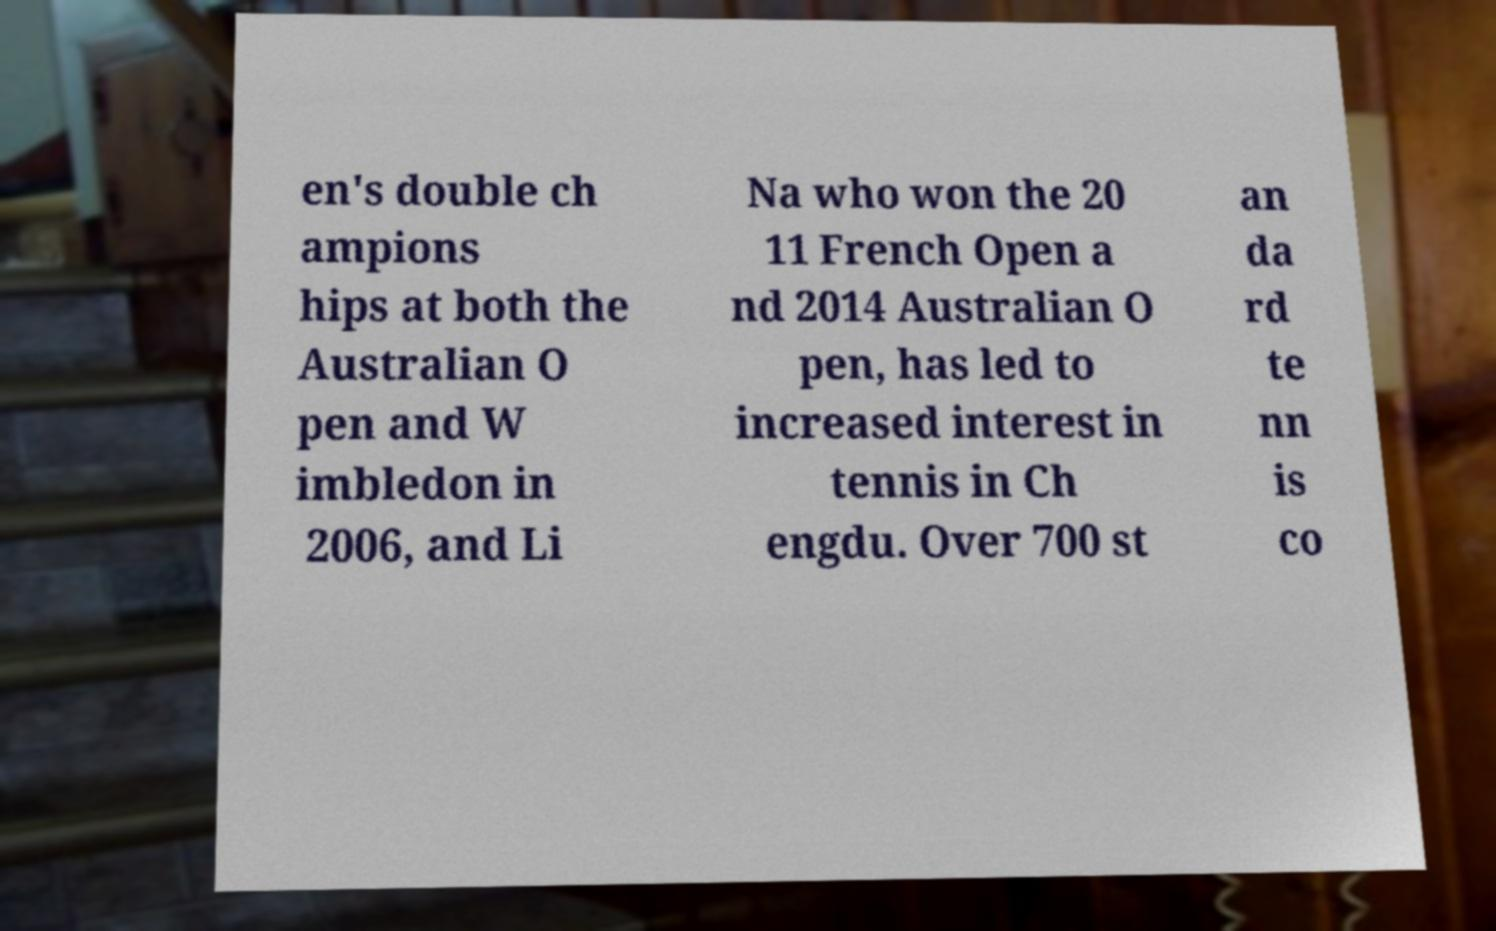I need the written content from this picture converted into text. Can you do that? en's double ch ampions hips at both the Australian O pen and W imbledon in 2006, and Li Na who won the 20 11 French Open a nd 2014 Australian O pen, has led to increased interest in tennis in Ch engdu. Over 700 st an da rd te nn is co 